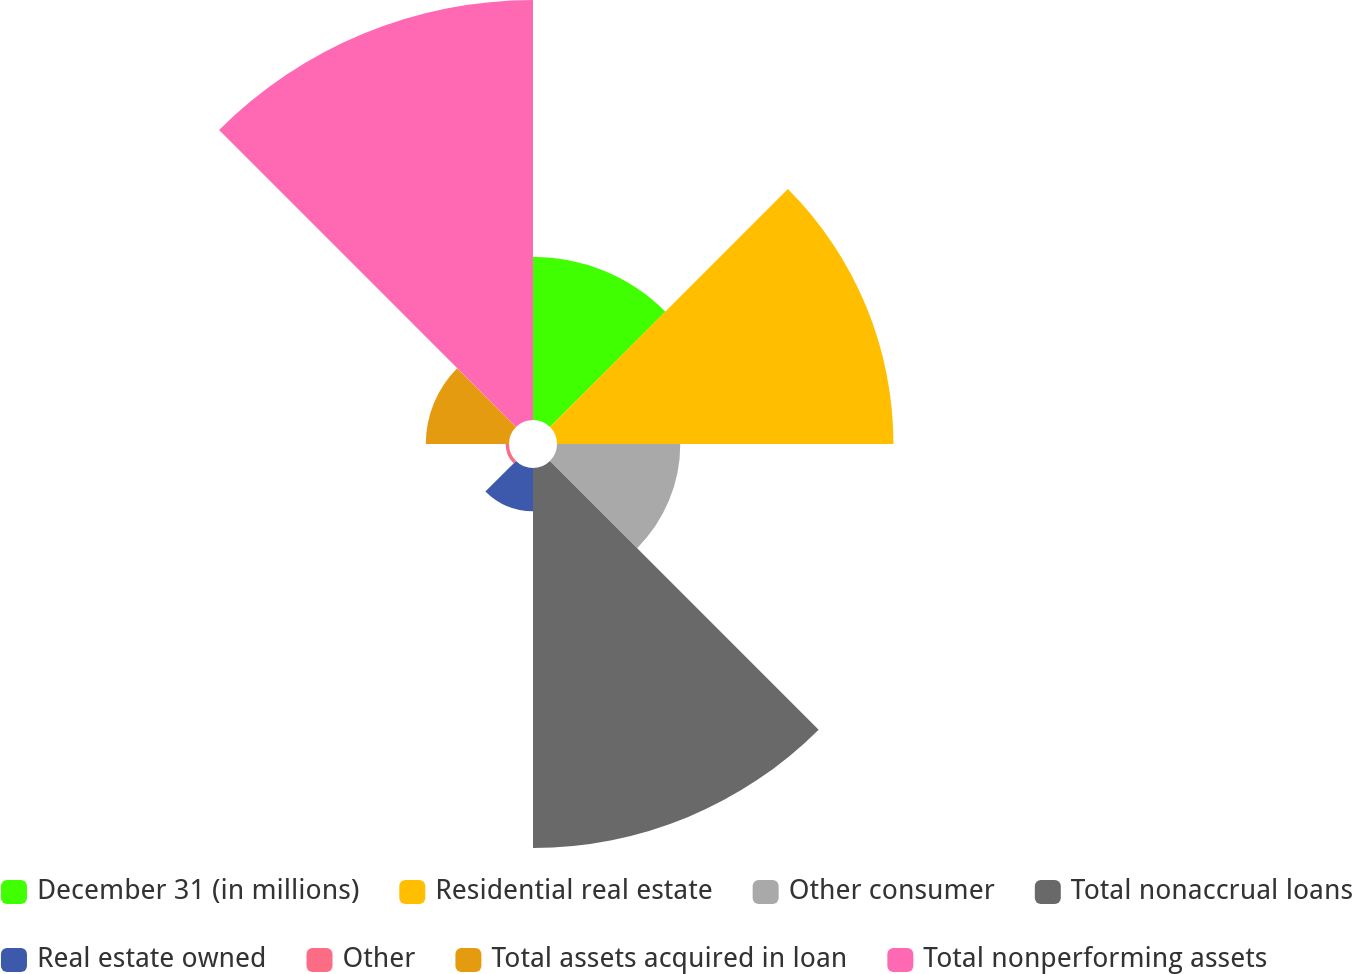Convert chart to OTSL. <chart><loc_0><loc_0><loc_500><loc_500><pie_chart><fcel>December 31 (in millions)<fcel>Residential real estate<fcel>Other consumer<fcel>Total nonaccrual loans<fcel>Real estate owned<fcel>Other<fcel>Total assets acquired in loan<fcel>Total nonperforming assets<nl><fcel>10.51%<fcel>21.67%<fcel>7.94%<fcel>24.47%<fcel>2.79%<fcel>0.22%<fcel>5.36%<fcel>27.05%<nl></chart> 